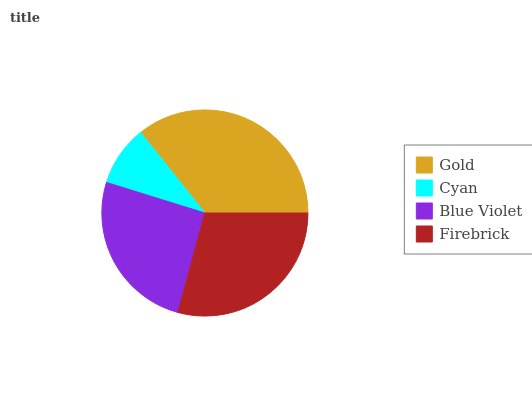Is Cyan the minimum?
Answer yes or no. Yes. Is Gold the maximum?
Answer yes or no. Yes. Is Blue Violet the minimum?
Answer yes or no. No. Is Blue Violet the maximum?
Answer yes or no. No. Is Blue Violet greater than Cyan?
Answer yes or no. Yes. Is Cyan less than Blue Violet?
Answer yes or no. Yes. Is Cyan greater than Blue Violet?
Answer yes or no. No. Is Blue Violet less than Cyan?
Answer yes or no. No. Is Firebrick the high median?
Answer yes or no. Yes. Is Blue Violet the low median?
Answer yes or no. Yes. Is Blue Violet the high median?
Answer yes or no. No. Is Cyan the low median?
Answer yes or no. No. 